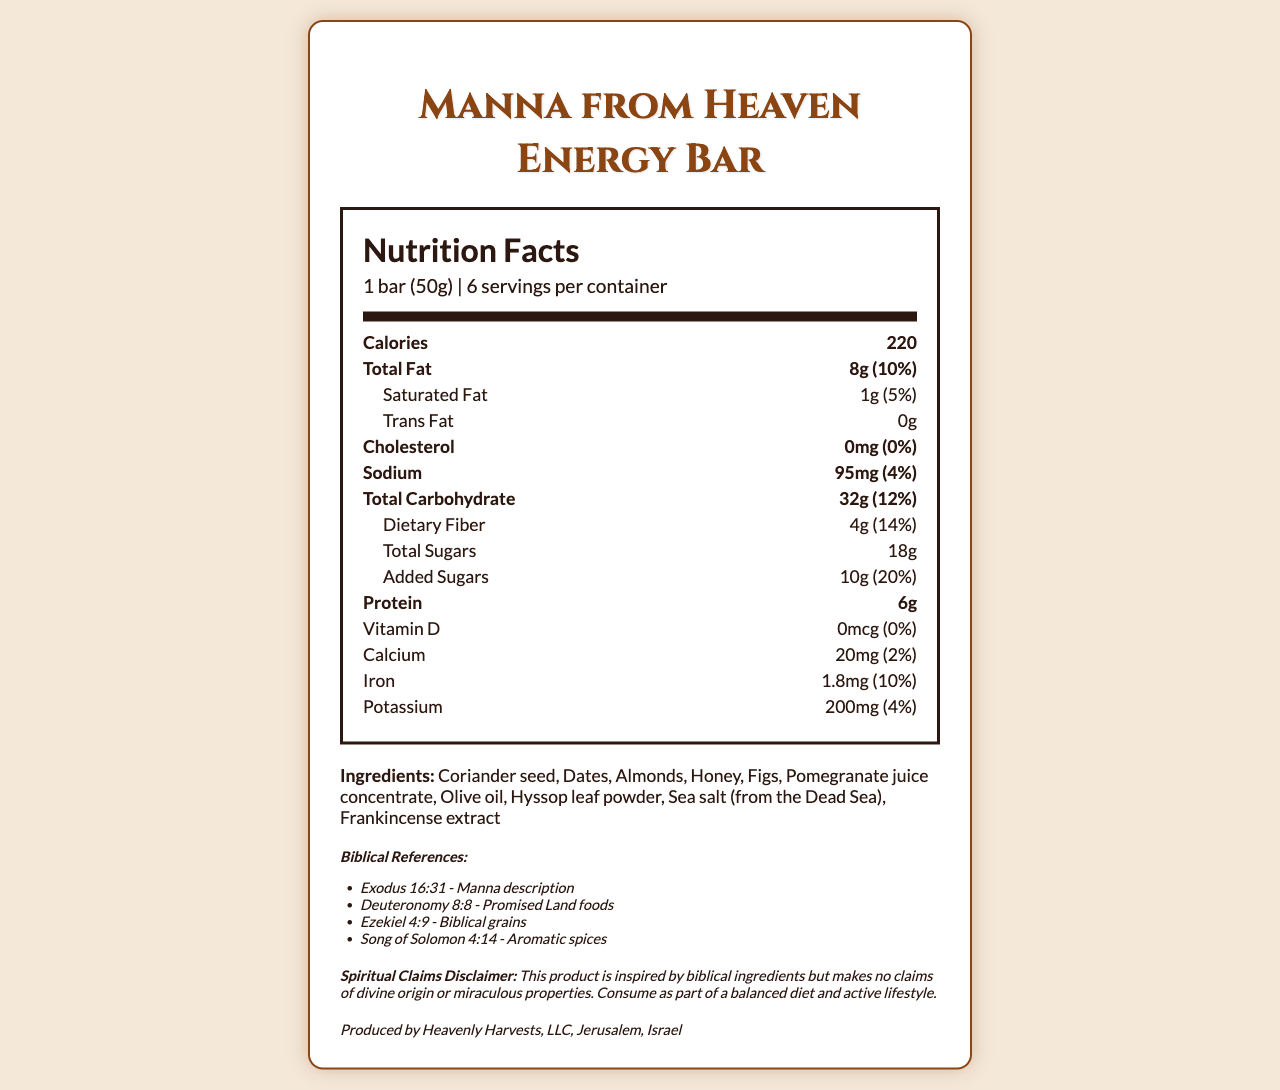how many calories are in one serving of the Manna from Heaven Energy Bar? According to the document, each serving contains 220 calories.
Answer: 220 how much total fat is in a serving of this energy bar? The document lists the total fat content per serving as 8g.
Answer: 8g what is the daily value percentage of dietary fiber in one serving? The document states that one serving provides 14% of the daily value for dietary fiber.
Answer: 14% list two biblical references mentioned in the document. The biblical references listed include Exodus 16:31 - Manna description, and Deuteronomy 8:8 - Promised Land foods.
Answer: Exodus 16:31, Deuteronomy 8:8 what allergen is explicitly mentioned in the allergen information section? The allergen information mentions that the product contains tree nuts (almonds).
Answer: Tree nuts (almonds) what is the total carbohydrate content in one serving? A. 28g B. 32g C. 15g D. 40g The document specifies that each serving contains 32g of total carbohydrates.
Answer: B how many biblical references are given in the document? I. Two II. Three III. Four IV. Five The document lists four biblical references.
Answer: III is there any trans fat in the Manna from Heaven Energy Bar? The document indicates that the trans fat content is 0g.
Answer: No does this product contain any cholesterol? The document shows that the cholesterol amount is 0mg.
Answer: No are there more than 50mg of sodium per serving in this energy bar? The document indicates that there are 95mg of sodium per serving, which is more than 50mg.
Answer: Yes summarize the main nutritional information and unique aspects of the Manna from Heaven Energy Bar. The document provides detailed nutritional information, a list of ingredients with biblical significance, and other pertinent information about the product's origins and claims.
Answer: The Manna from Heaven Energy Bar contains 220 calories per serving, with 8g of total fat, 32g of carbohydrates, 4g of dietary fiber, and 6g of protein. It includes unique biblical ingredients such as coriander seed, dates, and almonds, and is inspired by several biblical references. The product is produced by Heavenly Harvests, LLC in Jerusalem, Israel. does the document provide enough information to determine the exact manufacturing process of the Manna from Heaven Energy Bar? The document does not include details about the manufacturing process beyond stating the manufacturer and location.
Answer: No what ingredient gives the energy bar its aromatic spices as mentioned in the biblical references? The biblical reference from Song of Solomon 4:14 mentions aromatic spices, which is represented by the inclusion of frankincense extract in the ingredients list.
Answer: Frankincense extract 